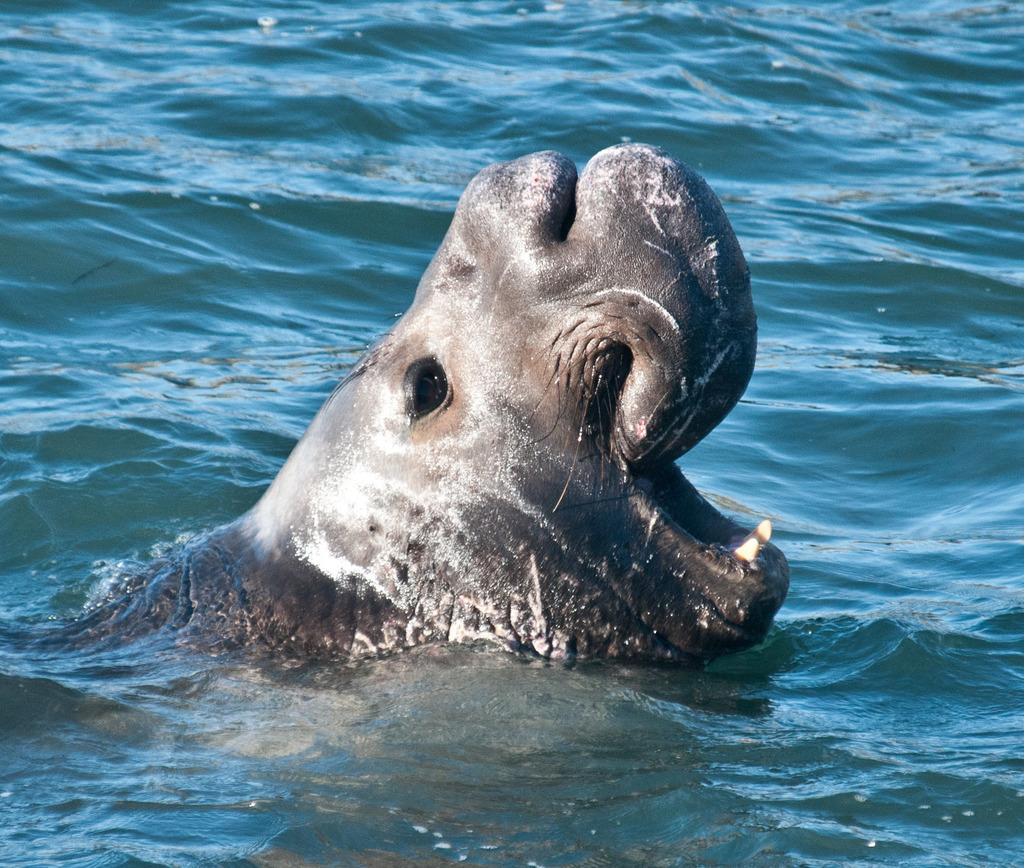What animal is the main subject of the image? There is a whale in the image. Where is the whale located? The whale is in the water. Is the whale stuck in quicksand in the image? No, there is no quicksand present in the image, and the whale is in the water. Can you see a hill in the background of the image? No, there is no hill visible in the image; it only features the whale in the water. 